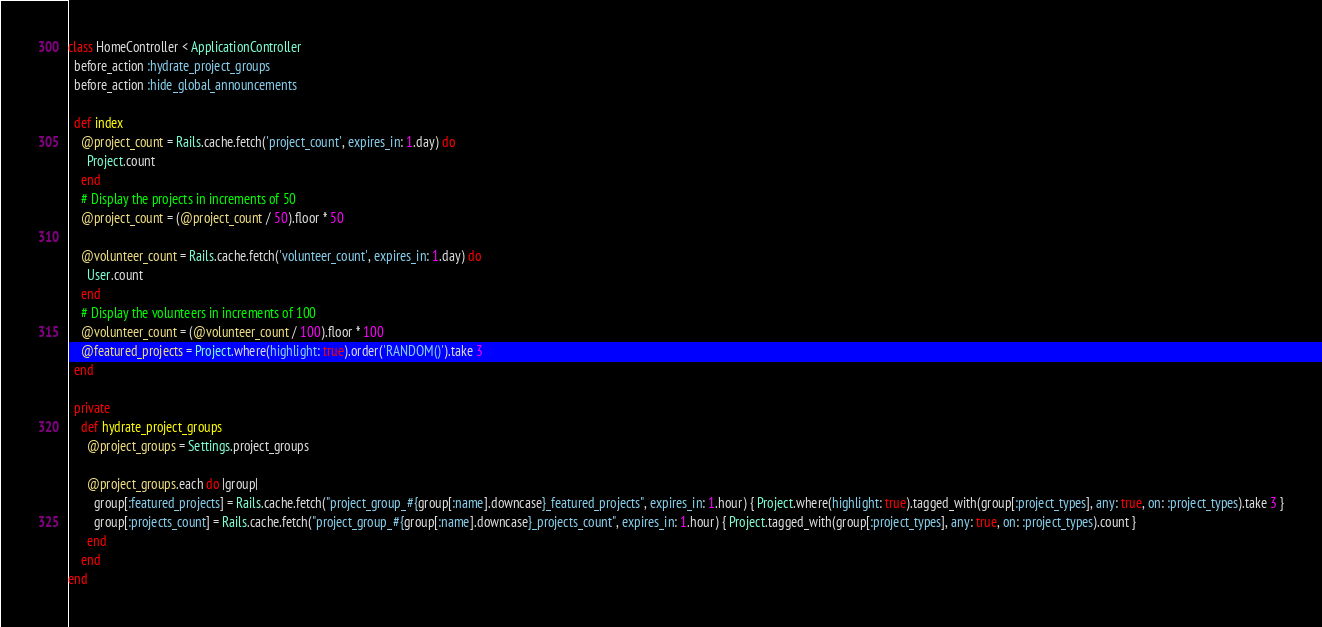<code> <loc_0><loc_0><loc_500><loc_500><_Ruby_>class HomeController < ApplicationController
  before_action :hydrate_project_groups
  before_action :hide_global_announcements

  def index
    @project_count = Rails.cache.fetch('project_count', expires_in: 1.day) do
      Project.count
    end
    # Display the projects in increments of 50
    @project_count = (@project_count / 50).floor * 50

    @volunteer_count = Rails.cache.fetch('volunteer_count', expires_in: 1.day) do
      User.count
    end
    # Display the volunteers in increments of 100
    @volunteer_count = (@volunteer_count / 100).floor * 100
    @featured_projects = Project.where(highlight: true).order('RANDOM()').take 3
  end

  private
    def hydrate_project_groups
      @project_groups = Settings.project_groups

      @project_groups.each do |group|
        group[:featured_projects] = Rails.cache.fetch("project_group_#{group[:name].downcase}_featured_projects", expires_in: 1.hour) { Project.where(highlight: true).tagged_with(group[:project_types], any: true, on: :project_types).take 3 }
        group[:projects_count] = Rails.cache.fetch("project_group_#{group[:name].downcase}_projects_count", expires_in: 1.hour) { Project.tagged_with(group[:project_types], any: true, on: :project_types).count }
      end
    end
end
</code> 